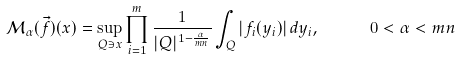Convert formula to latex. <formula><loc_0><loc_0><loc_500><loc_500>\mathcal { M } _ { \alpha } ( \vec { f } ) ( x ) = \sup _ { Q \ni x } \prod _ { i = 1 } ^ { m } \frac { 1 } { | Q | ^ { 1 - \frac { \alpha } { m n } } } \int _ { Q } | f _ { i } ( y _ { i } ) | \, d y _ { i } , \quad \ \ 0 < \alpha < m n</formula> 